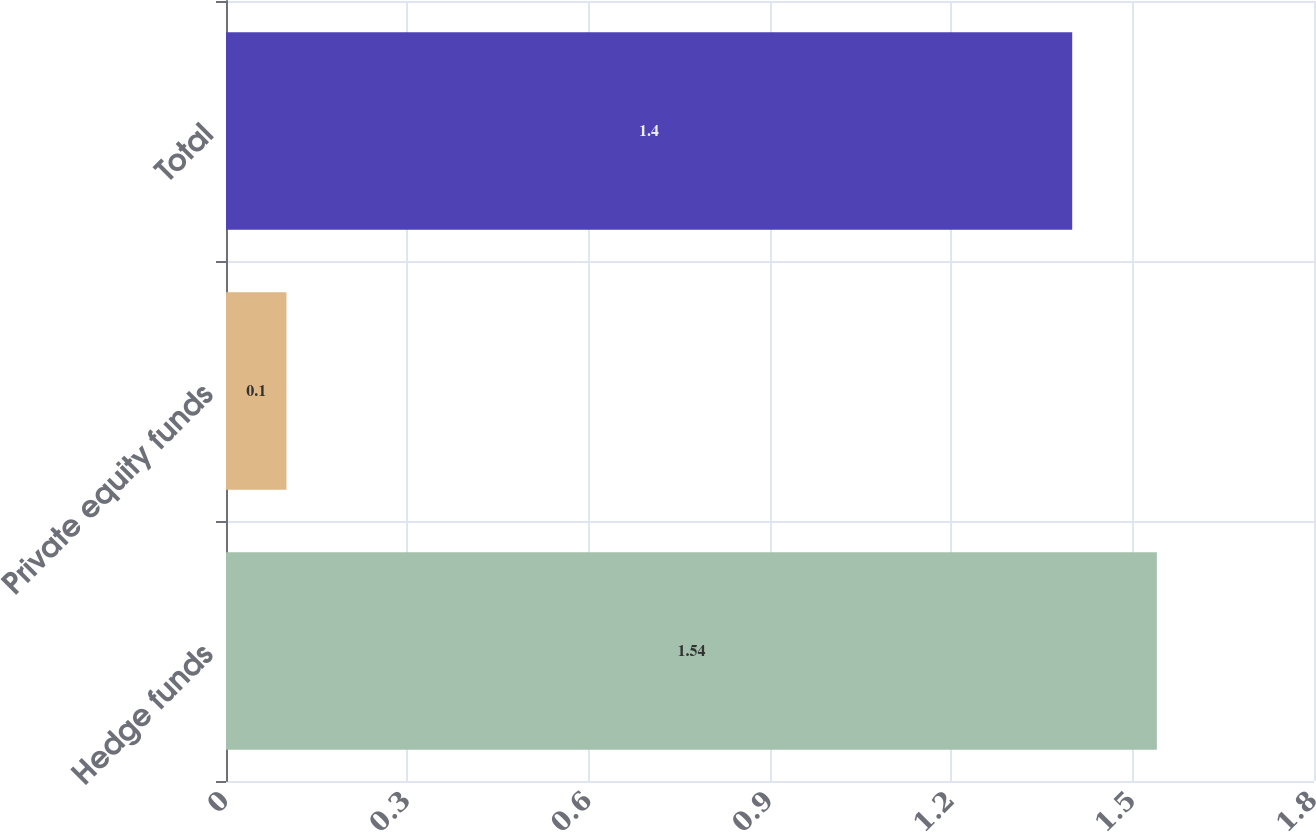Convert chart. <chart><loc_0><loc_0><loc_500><loc_500><bar_chart><fcel>Hedge funds<fcel>Private equity funds<fcel>Total<nl><fcel>1.54<fcel>0.1<fcel>1.4<nl></chart> 